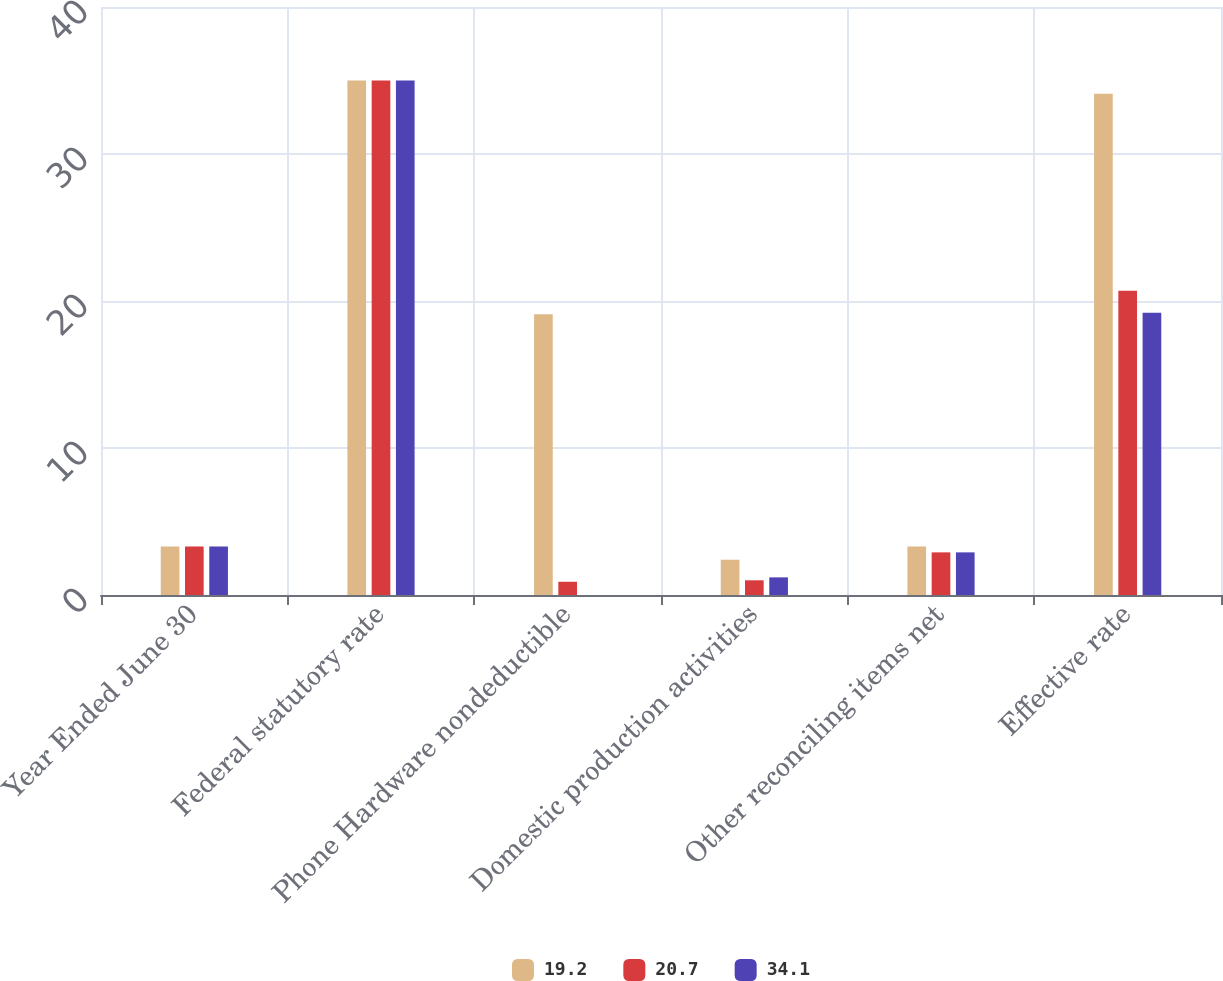<chart> <loc_0><loc_0><loc_500><loc_500><stacked_bar_chart><ecel><fcel>Year Ended June 30<fcel>Federal statutory rate<fcel>Phone Hardware nondeductible<fcel>Domestic production activities<fcel>Other reconciling items net<fcel>Effective rate<nl><fcel>19.2<fcel>3.3<fcel>35<fcel>19.1<fcel>2.4<fcel>3.3<fcel>34.1<nl><fcel>20.7<fcel>3.3<fcel>35<fcel>0.9<fcel>1<fcel>2.9<fcel>20.7<nl><fcel>34.1<fcel>3.3<fcel>35<fcel>0<fcel>1.2<fcel>2.9<fcel>19.2<nl></chart> 